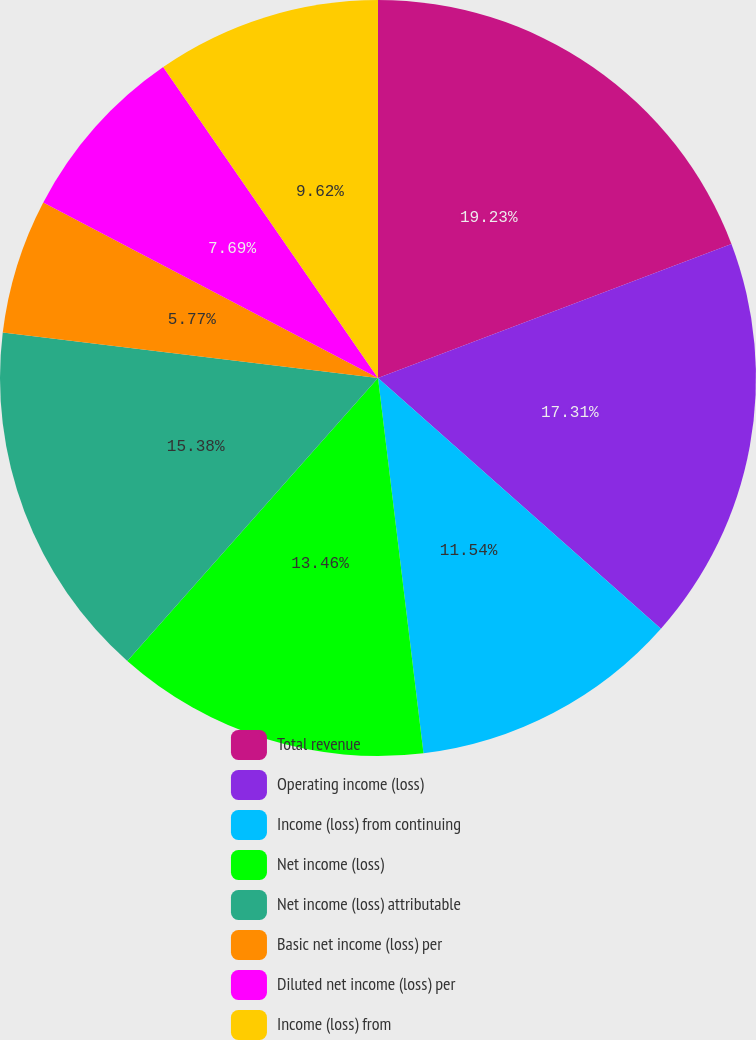Convert chart. <chart><loc_0><loc_0><loc_500><loc_500><pie_chart><fcel>Total revenue<fcel>Operating income (loss)<fcel>Income (loss) from continuing<fcel>Net income (loss)<fcel>Net income (loss) attributable<fcel>Basic net income (loss) per<fcel>Diluted net income (loss) per<fcel>Income (loss) from<nl><fcel>19.23%<fcel>17.31%<fcel>11.54%<fcel>13.46%<fcel>15.38%<fcel>5.77%<fcel>7.69%<fcel>9.62%<nl></chart> 